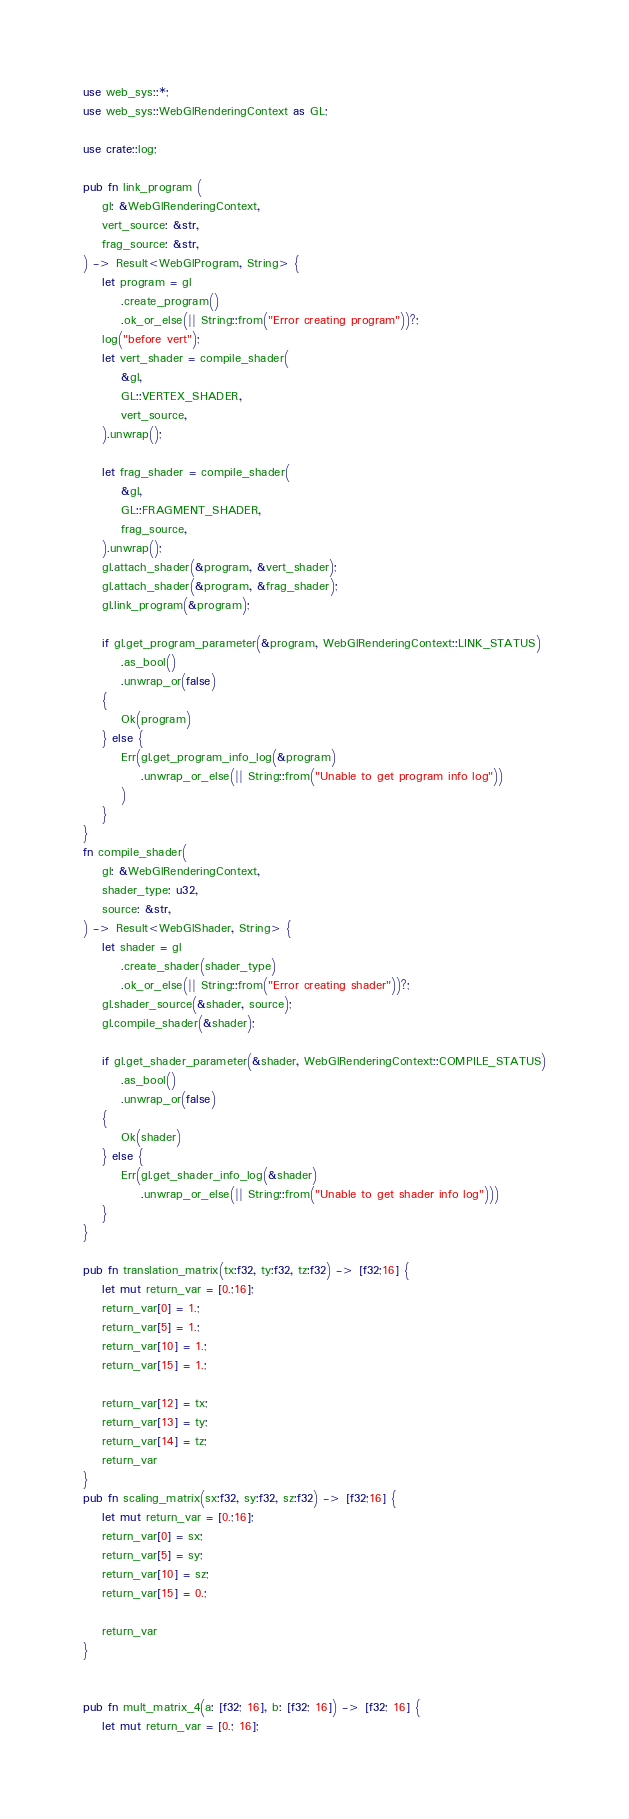Convert code to text. <code><loc_0><loc_0><loc_500><loc_500><_Rust_>use web_sys::*;
use web_sys::WebGlRenderingContext as GL;

use crate::log;

pub fn link_program (
    gl: &WebGlRenderingContext,
    vert_source: &str,
    frag_source: &str,
) -> Result<WebGlProgram, String> {
    let program = gl
        .create_program()
        .ok_or_else(|| String::from("Error creating program"))?;
    log("before vert");
    let vert_shader = compile_shader(
        &gl,
        GL::VERTEX_SHADER,
        vert_source,
    ).unwrap();

    let frag_shader = compile_shader(
        &gl,
        GL::FRAGMENT_SHADER,
        frag_source,
    ).unwrap();
    gl.attach_shader(&program, &vert_shader);
    gl.attach_shader(&program, &frag_shader);
    gl.link_program(&program);

    if gl.get_program_parameter(&program, WebGlRenderingContext::LINK_STATUS) 
        .as_bool()
        .unwrap_or(false)
    {
        Ok(program)
    } else {
        Err(gl.get_program_info_log(&program)
            .unwrap_or_else(|| String::from("Unable to get program info log"))
        )
    }
}
fn compile_shader(
    gl: &WebGlRenderingContext,
    shader_type: u32,
    source: &str,
) -> Result<WebGlShader, String> {
    let shader = gl
        .create_shader(shader_type)
        .ok_or_else(|| String::from("Error creating shader"))?;
    gl.shader_source(&shader, source);
    gl.compile_shader(&shader);
    
    if gl.get_shader_parameter(&shader, WebGlRenderingContext::COMPILE_STATUS)
        .as_bool()
        .unwrap_or(false) 
    {
        Ok(shader)
    } else {
        Err(gl.get_shader_info_log(&shader)
            .unwrap_or_else(|| String::from("Unable to get shader info log")))
    }
}

pub fn translation_matrix(tx:f32, ty:f32, tz:f32) -> [f32;16] {
    let mut return_var = [0.;16];
    return_var[0] = 1.;
    return_var[5] = 1.;
    return_var[10] = 1.;
    return_var[15] = 1.;

    return_var[12] = tx;
    return_var[13] = ty;
    return_var[14] = tz;
    return_var
}
pub fn scaling_matrix(sx:f32, sy:f32, sz:f32) -> [f32;16] {
    let mut return_var = [0.;16];
    return_var[0] = sx;
    return_var[5] = sy;
    return_var[10] = sz;
    return_var[15] = 0.;

    return_var
}


pub fn mult_matrix_4(a: [f32; 16], b: [f32; 16]) -> [f32; 16] {
    let mut return_var = [0.; 16];
</code> 